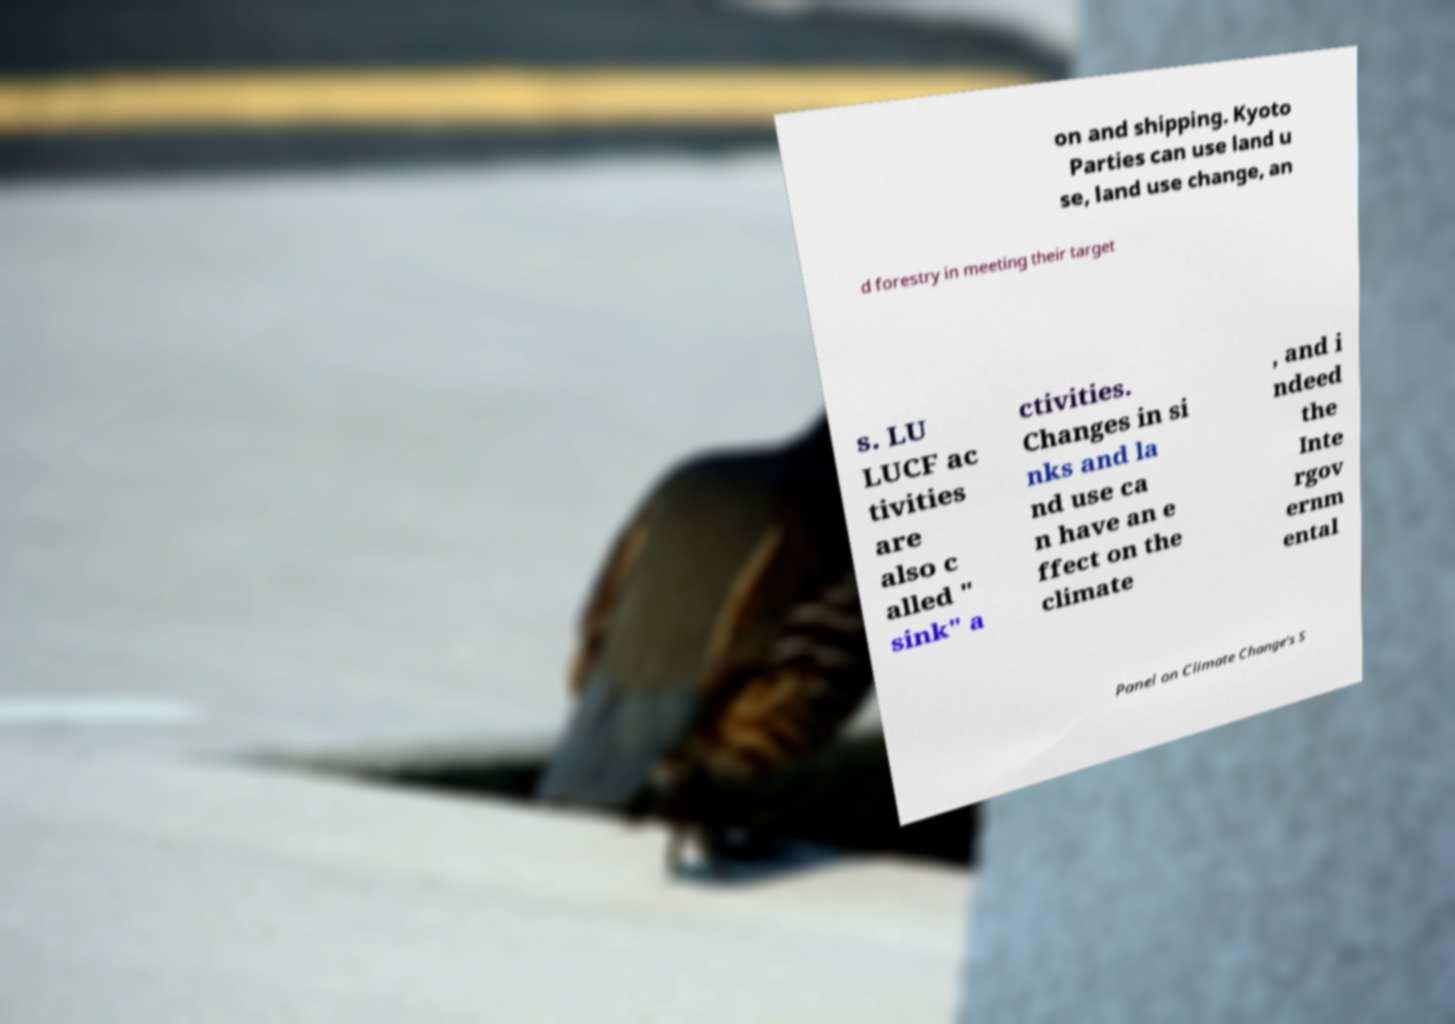For documentation purposes, I need the text within this image transcribed. Could you provide that? on and shipping. Kyoto Parties can use land u se, land use change, an d forestry in meeting their target s. LU LUCF ac tivities are also c alled " sink" a ctivities. Changes in si nks and la nd use ca n have an e ffect on the climate , and i ndeed the Inte rgov ernm ental Panel on Climate Change's S 